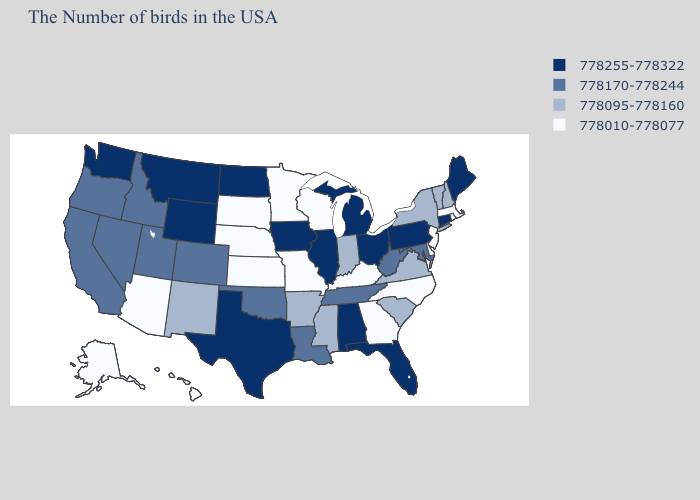Which states hav the highest value in the South?
Be succinct. Florida, Alabama, Texas. Does Nevada have the lowest value in the USA?
Quick response, please. No. What is the value of Mississippi?
Short answer required. 778095-778160. Among the states that border Colorado , which have the highest value?
Write a very short answer. Wyoming. What is the value of Michigan?
Quick response, please. 778255-778322. What is the lowest value in the USA?
Be succinct. 778010-778077. Among the states that border Arkansas , does Texas have the highest value?
Keep it brief. Yes. Among the states that border Wisconsin , does Minnesota have the highest value?
Give a very brief answer. No. Does Alaska have the lowest value in the USA?
Keep it brief. Yes. Name the states that have a value in the range 778255-778322?
Answer briefly. Maine, Connecticut, Pennsylvania, Ohio, Florida, Michigan, Alabama, Illinois, Iowa, Texas, North Dakota, Wyoming, Montana, Washington. Name the states that have a value in the range 778170-778244?
Quick response, please. Maryland, West Virginia, Tennessee, Louisiana, Oklahoma, Colorado, Utah, Idaho, Nevada, California, Oregon. Name the states that have a value in the range 778010-778077?
Write a very short answer. Massachusetts, Rhode Island, New Jersey, Delaware, North Carolina, Georgia, Kentucky, Wisconsin, Missouri, Minnesota, Kansas, Nebraska, South Dakota, Arizona, Alaska, Hawaii. How many symbols are there in the legend?
Quick response, please. 4. Which states hav the highest value in the MidWest?
Concise answer only. Ohio, Michigan, Illinois, Iowa, North Dakota. What is the value of Kansas?
Give a very brief answer. 778010-778077. 